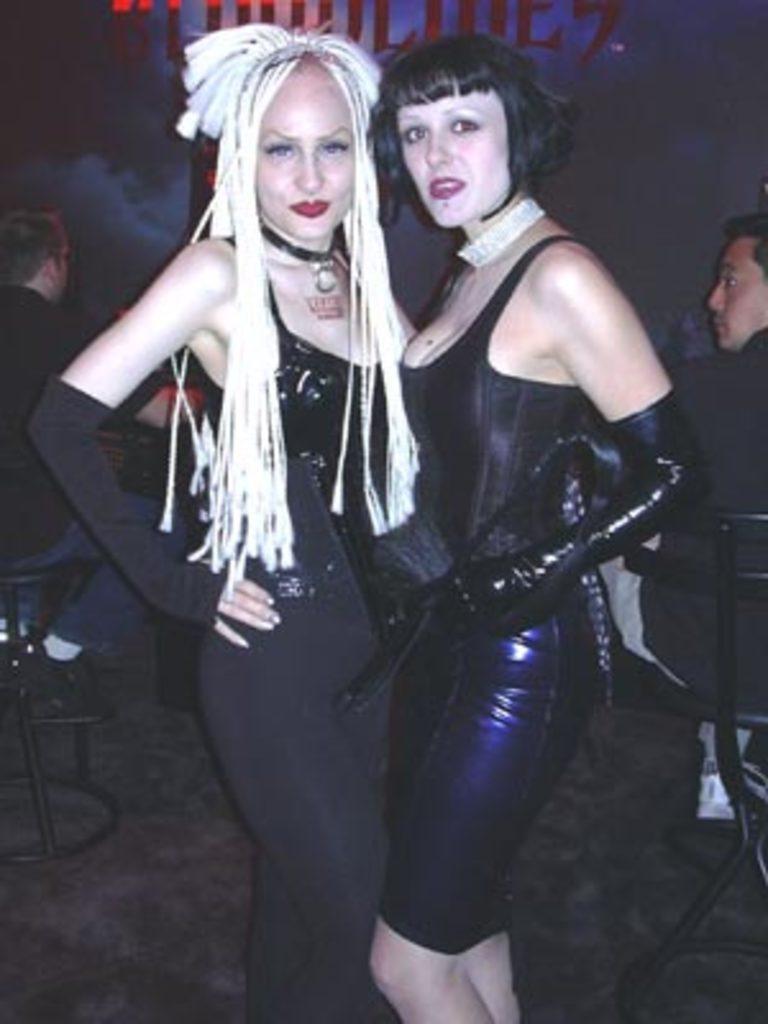Can you describe this image briefly? In this picture I can see the two girls in the middle, they are wearing the black color dresses, two men are sitting on the chairs on either side of this image, at the top it looks like the text. 